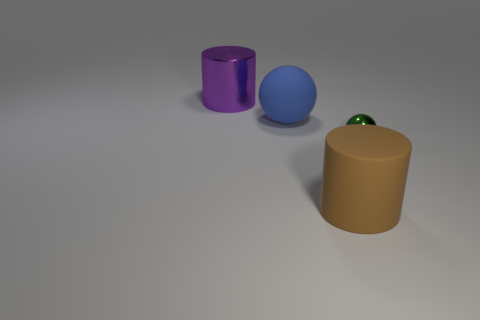Add 2 big rubber spheres. How many objects exist? 6 Add 4 tiny green objects. How many tiny green objects are left? 5 Add 3 large brown things. How many large brown things exist? 4 Subtract 0 red cylinders. How many objects are left? 4 Subtract all blue cylinders. Subtract all metal cylinders. How many objects are left? 3 